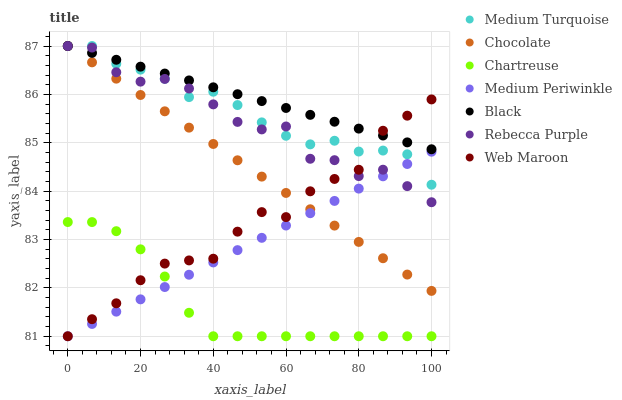Does Chartreuse have the minimum area under the curve?
Answer yes or no. Yes. Does Black have the maximum area under the curve?
Answer yes or no. Yes. Does Medium Periwinkle have the minimum area under the curve?
Answer yes or no. No. Does Medium Periwinkle have the maximum area under the curve?
Answer yes or no. No. Is Medium Periwinkle the smoothest?
Answer yes or no. Yes. Is Rebecca Purple the roughest?
Answer yes or no. Yes. Is Chocolate the smoothest?
Answer yes or no. No. Is Chocolate the roughest?
Answer yes or no. No. Does Web Maroon have the lowest value?
Answer yes or no. Yes. Does Chocolate have the lowest value?
Answer yes or no. No. Does Medium Turquoise have the highest value?
Answer yes or no. Yes. Does Medium Periwinkle have the highest value?
Answer yes or no. No. Is Chartreuse less than Chocolate?
Answer yes or no. Yes. Is Medium Turquoise greater than Chartreuse?
Answer yes or no. Yes. Does Black intersect Medium Turquoise?
Answer yes or no. Yes. Is Black less than Medium Turquoise?
Answer yes or no. No. Is Black greater than Medium Turquoise?
Answer yes or no. No. Does Chartreuse intersect Chocolate?
Answer yes or no. No. 